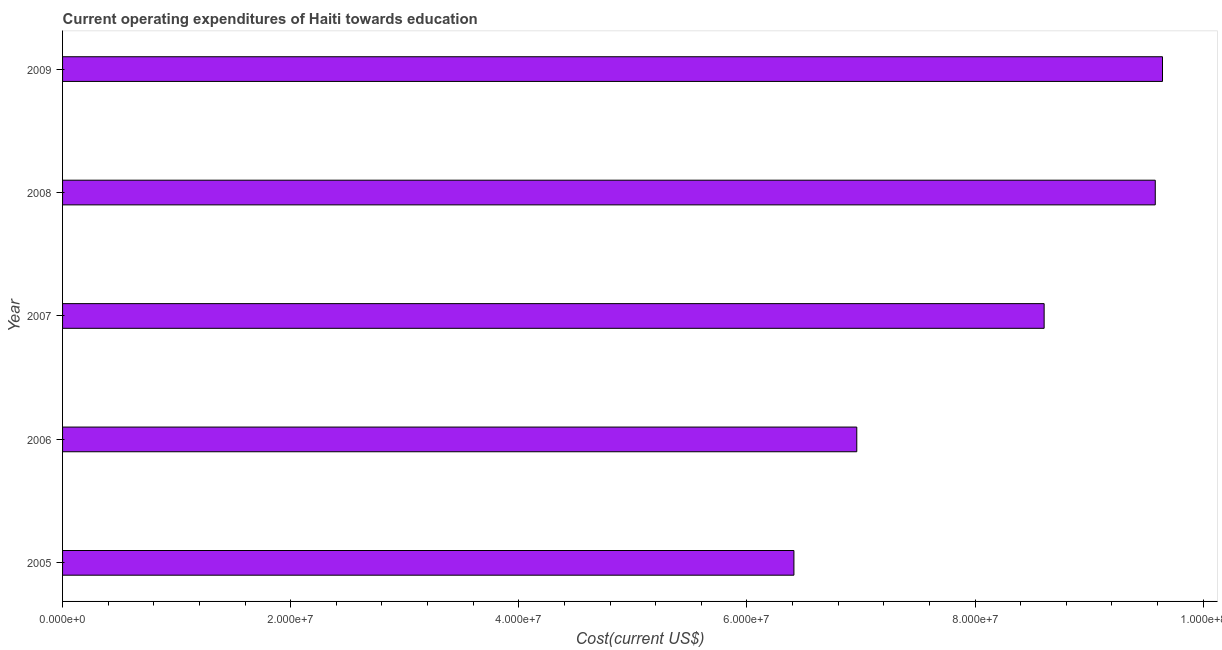Does the graph contain any zero values?
Keep it short and to the point. No. Does the graph contain grids?
Keep it short and to the point. No. What is the title of the graph?
Your answer should be very brief. Current operating expenditures of Haiti towards education. What is the label or title of the X-axis?
Give a very brief answer. Cost(current US$). What is the label or title of the Y-axis?
Your answer should be very brief. Year. What is the education expenditure in 2009?
Make the answer very short. 9.64e+07. Across all years, what is the maximum education expenditure?
Provide a short and direct response. 9.64e+07. Across all years, what is the minimum education expenditure?
Offer a very short reply. 6.41e+07. In which year was the education expenditure minimum?
Your response must be concise. 2005. What is the sum of the education expenditure?
Your response must be concise. 4.12e+08. What is the difference between the education expenditure in 2005 and 2008?
Give a very brief answer. -3.17e+07. What is the average education expenditure per year?
Offer a terse response. 8.24e+07. What is the median education expenditure?
Offer a terse response. 8.61e+07. Do a majority of the years between 2009 and 2007 (inclusive) have education expenditure greater than 60000000 US$?
Provide a succinct answer. Yes. What is the ratio of the education expenditure in 2005 to that in 2006?
Keep it short and to the point. 0.92. Is the difference between the education expenditure in 2006 and 2007 greater than the difference between any two years?
Ensure brevity in your answer.  No. What is the difference between the highest and the second highest education expenditure?
Your answer should be very brief. 6.34e+05. What is the difference between the highest and the lowest education expenditure?
Offer a very short reply. 3.23e+07. In how many years, is the education expenditure greater than the average education expenditure taken over all years?
Provide a short and direct response. 3. Are all the bars in the graph horizontal?
Ensure brevity in your answer.  Yes. How many years are there in the graph?
Keep it short and to the point. 5. What is the difference between two consecutive major ticks on the X-axis?
Keep it short and to the point. 2.00e+07. What is the Cost(current US$) in 2005?
Ensure brevity in your answer.  6.41e+07. What is the Cost(current US$) in 2006?
Give a very brief answer. 6.96e+07. What is the Cost(current US$) of 2007?
Provide a short and direct response. 8.61e+07. What is the Cost(current US$) of 2008?
Your response must be concise. 9.58e+07. What is the Cost(current US$) of 2009?
Keep it short and to the point. 9.64e+07. What is the difference between the Cost(current US$) in 2005 and 2006?
Give a very brief answer. -5.51e+06. What is the difference between the Cost(current US$) in 2005 and 2007?
Offer a very short reply. -2.19e+07. What is the difference between the Cost(current US$) in 2005 and 2008?
Your response must be concise. -3.17e+07. What is the difference between the Cost(current US$) in 2005 and 2009?
Keep it short and to the point. -3.23e+07. What is the difference between the Cost(current US$) in 2006 and 2007?
Your answer should be compact. -1.64e+07. What is the difference between the Cost(current US$) in 2006 and 2008?
Provide a short and direct response. -2.62e+07. What is the difference between the Cost(current US$) in 2006 and 2009?
Keep it short and to the point. -2.68e+07. What is the difference between the Cost(current US$) in 2007 and 2008?
Offer a very short reply. -9.74e+06. What is the difference between the Cost(current US$) in 2007 and 2009?
Keep it short and to the point. -1.04e+07. What is the difference between the Cost(current US$) in 2008 and 2009?
Your answer should be compact. -6.34e+05. What is the ratio of the Cost(current US$) in 2005 to that in 2006?
Offer a terse response. 0.92. What is the ratio of the Cost(current US$) in 2005 to that in 2007?
Ensure brevity in your answer.  0.74. What is the ratio of the Cost(current US$) in 2005 to that in 2008?
Provide a succinct answer. 0.67. What is the ratio of the Cost(current US$) in 2005 to that in 2009?
Provide a short and direct response. 0.67. What is the ratio of the Cost(current US$) in 2006 to that in 2007?
Ensure brevity in your answer.  0.81. What is the ratio of the Cost(current US$) in 2006 to that in 2008?
Provide a short and direct response. 0.73. What is the ratio of the Cost(current US$) in 2006 to that in 2009?
Offer a very short reply. 0.72. What is the ratio of the Cost(current US$) in 2007 to that in 2008?
Provide a short and direct response. 0.9. What is the ratio of the Cost(current US$) in 2007 to that in 2009?
Your response must be concise. 0.89. 